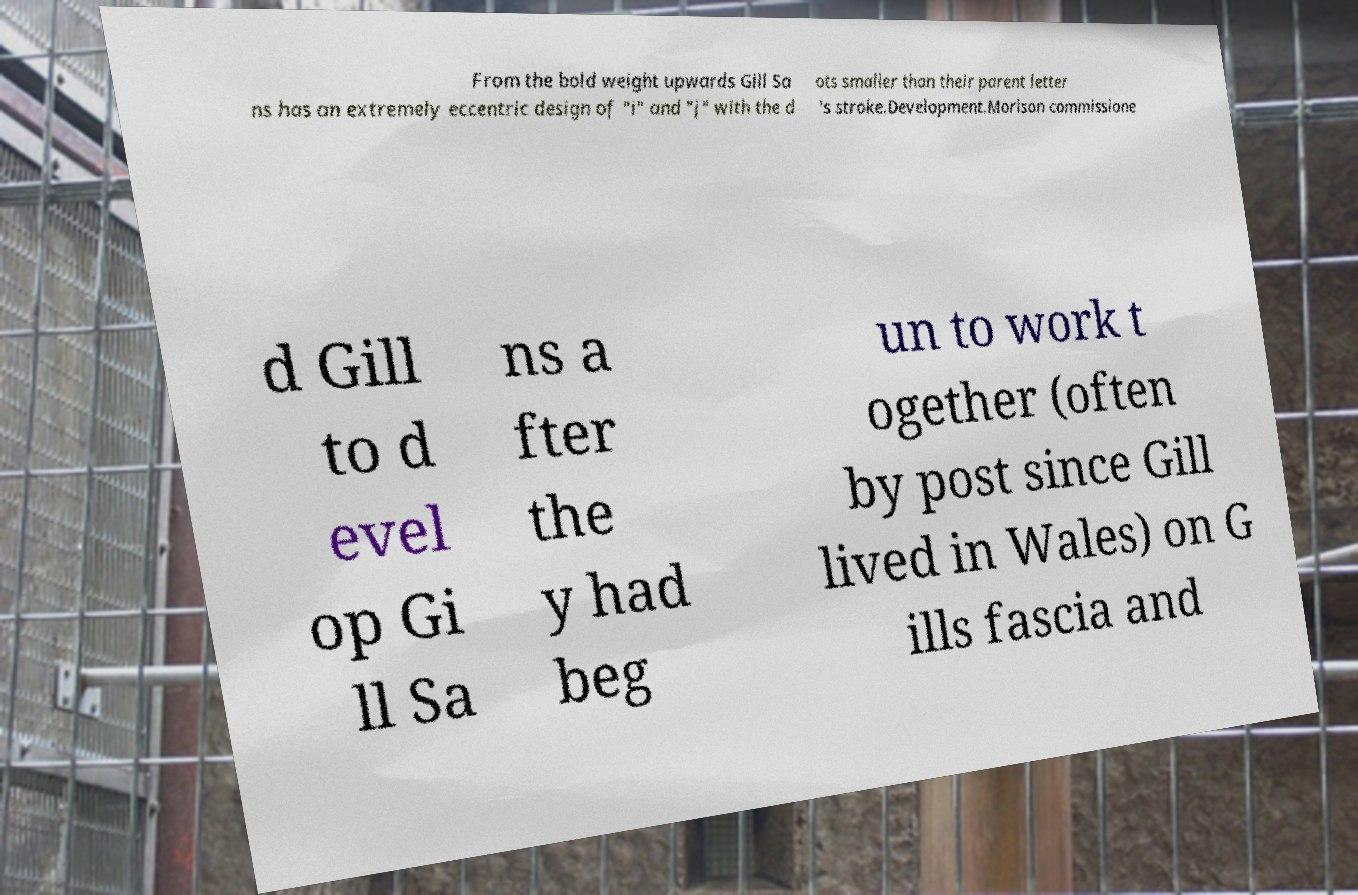For documentation purposes, I need the text within this image transcribed. Could you provide that? From the bold weight upwards Gill Sa ns has an extremely eccentric design of "i" and "j" with the d ots smaller than their parent letter 's stroke.Development.Morison commissione d Gill to d evel op Gi ll Sa ns a fter the y had beg un to work t ogether (often by post since Gill lived in Wales) on G ills fascia and 